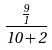<formula> <loc_0><loc_0><loc_500><loc_500>\frac { \frac { 9 } { 1 } } { 1 0 + 2 }</formula> 